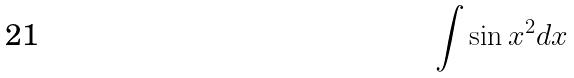Convert formula to latex. <formula><loc_0><loc_0><loc_500><loc_500>\int \sin x ^ { 2 } d x</formula> 